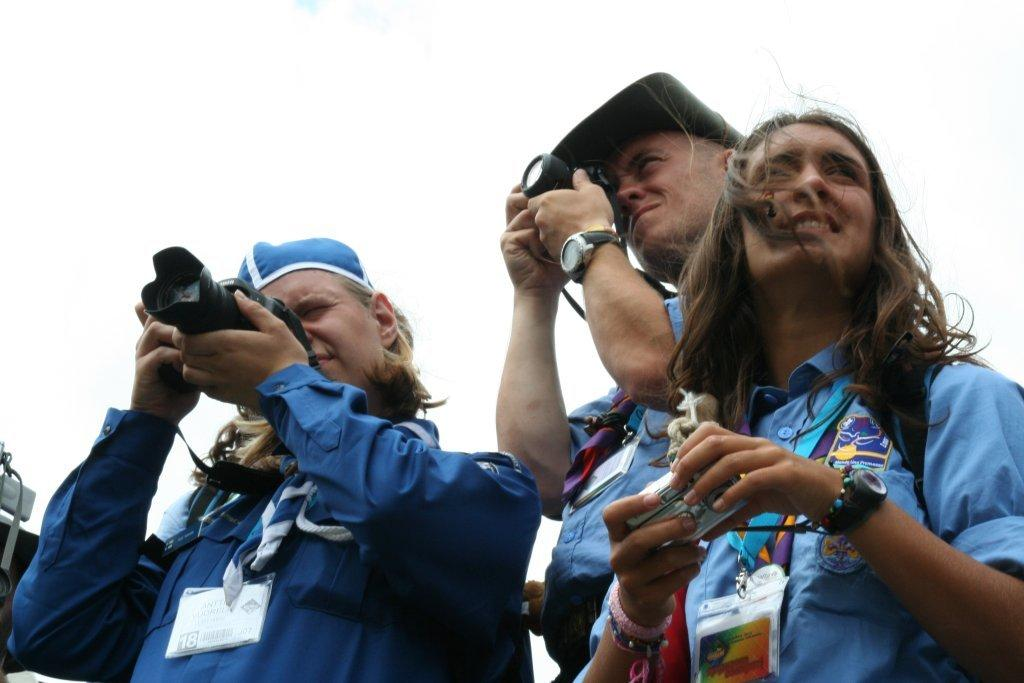How many people are in the image? There are three people in the image. What are the people wearing? The people are wearing blue shirts. What can be seen on the people's clothing? The people have tags on their shirts. What are the people holding in their hands? The people are holding cameras in their hands. What type of box can be seen in the image? There is no box present in the image. What season is it in the image? The provided facts do not give any information about the season, so it cannot be determined from the image. 